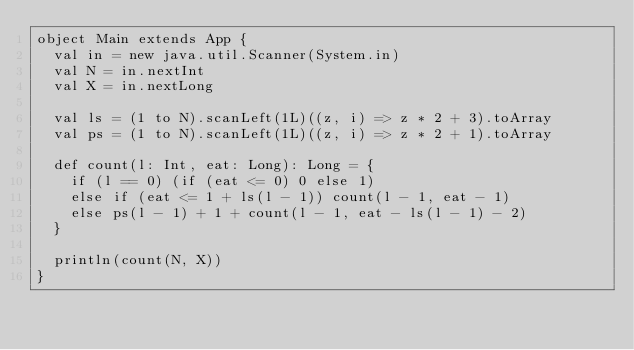Convert code to text. <code><loc_0><loc_0><loc_500><loc_500><_Scala_>object Main extends App {
  val in = new java.util.Scanner(System.in)
  val N = in.nextInt
  val X = in.nextLong

  val ls = (1 to N).scanLeft(1L)((z, i) => z * 2 + 3).toArray
  val ps = (1 to N).scanLeft(1L)((z, i) => z * 2 + 1).toArray

  def count(l: Int, eat: Long): Long = {
    if (l == 0) (if (eat <= 0) 0 else 1)
    else if (eat <= 1 + ls(l - 1)) count(l - 1, eat - 1)
    else ps(l - 1) + 1 + count(l - 1, eat - ls(l - 1) - 2)
  }

  println(count(N, X))
}</code> 